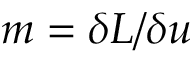Convert formula to latex. <formula><loc_0><loc_0><loc_500><loc_500>m = \delta L / \delta u</formula> 